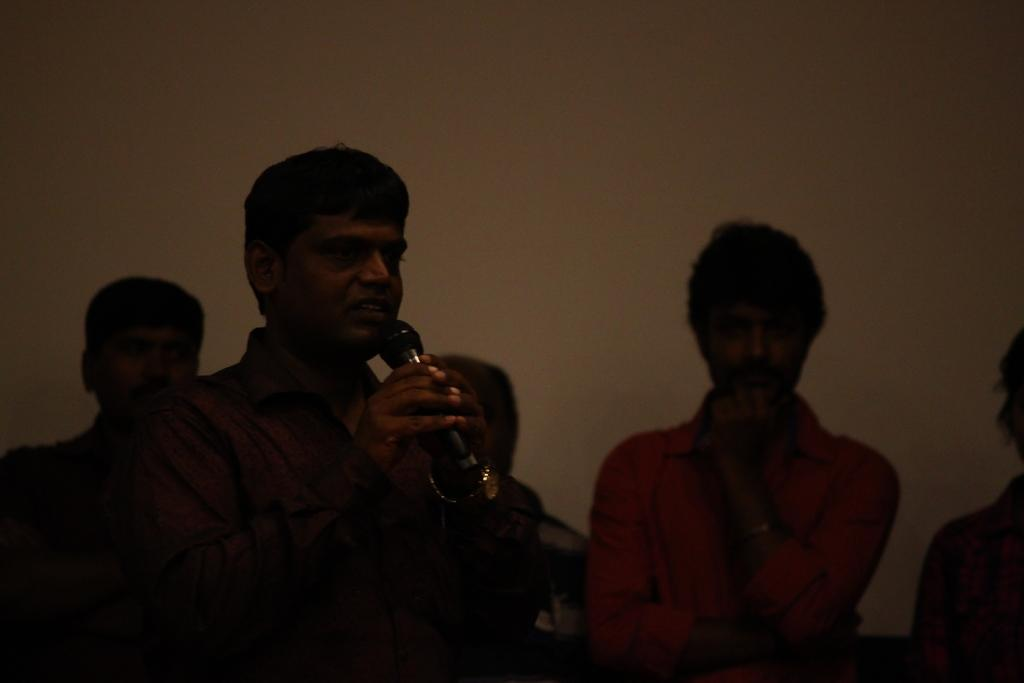Who is the main subject in the image? There is a man in the image. What is the man doing in the image? The man is standing in the image. What object is the man holding in his hand? The man is holding a microphone in his hand. Can you describe the people behind the man? There are people behind the man, but their specific actions or features are not mentioned in the provided facts. How many legs does the microphone have in the image? The microphone is an object and does not have legs; it is held by the man in the image. 